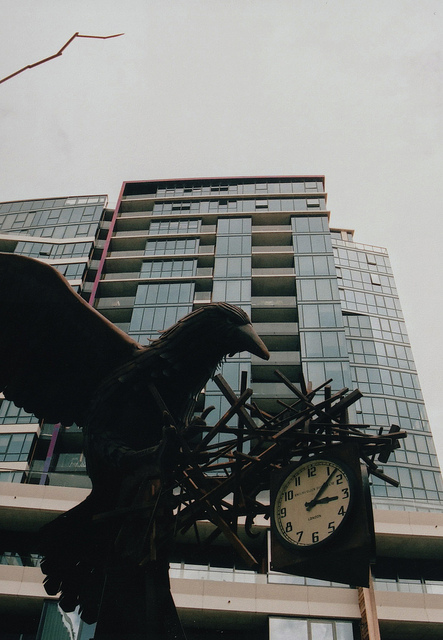Identify the text displayed in this image. 1 2 3 5 6 4 7 8 9 10 11 12 